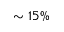Convert formula to latex. <formula><loc_0><loc_0><loc_500><loc_500>\sim 1 5 \%</formula> 